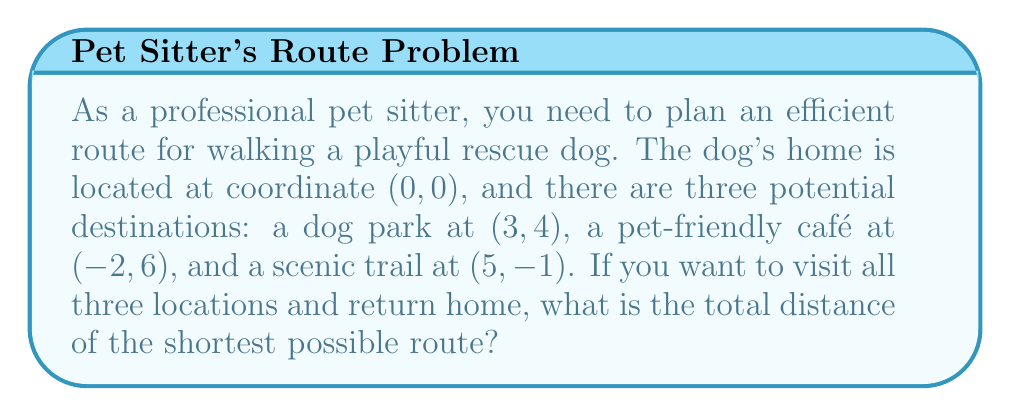Solve this math problem. To solve this problem, we need to calculate the distances between all points and find the shortest path that visits all locations. Let's approach this step-by-step:

1) First, let's calculate the distances between all points using the distance formula:
   $d = \sqrt{(x_2-x_1)^2 + (y_2-y_1)^2}$

   Home (H): (0, 0)
   Dog Park (P): (3, 4)
   Café (C): (-2, 6)
   Trail (T): (5, -1)

   HP = $\sqrt{(3-0)^2 + (4-0)^2} = 5$
   HC = $\sqrt{(-2-0)^2 + (6-0)^2} = \sqrt{40} \approx 6.32$
   HT = $\sqrt{(5-0)^2 + (-1-0)^2} = \sqrt{26} \approx 5.10$
   PC = $\sqrt{(-2-3)^2 + (6-4)^2} = 5.39$
   PT = $\sqrt{(5-3)^2 + (-1-4)^2} = \sqrt{29} \approx 5.39$
   CT = $\sqrt{(5-(-2))^2 + (-1-6)^2} = \sqrt{98} \approx 9.90$

2) Now, we need to find the shortest route that visits all points. This is known as the Traveling Salesman Problem. For a small number of points, we can check all possible routes:

   H-P-C-T-H: 5 + 5.39 + 9.90 + 5.10 = 25.39
   H-P-T-C-H: 5 + 5.39 + 9.90 + 6.32 = 26.61
   H-C-P-T-H: 6.32 + 5.39 + 5.39 + 5.10 = 22.20
   H-C-T-P-H: 6.32 + 9.90 + 5.39 + 5 = 26.61
   H-T-P-C-H: 5.10 + 5.39 + 5.39 + 6.32 = 22.20
   H-T-C-P-H: 5.10 + 9.90 + 5.39 + 5 = 25.39

3) The shortest routes are H-C-P-T-H and H-T-P-C-H, both with a total distance of 22.20 units.
Answer: The total distance of the shortest possible route is $22.20$ units. 